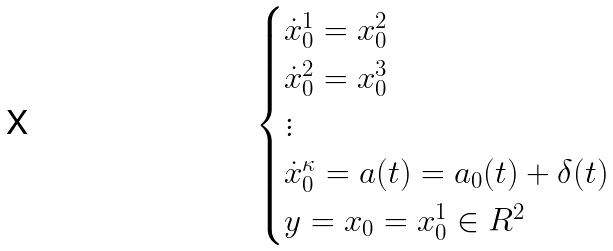<formula> <loc_0><loc_0><loc_500><loc_500>\begin{cases} \dot { x } _ { 0 } ^ { 1 } = x _ { 0 } ^ { 2 } \\ \dot { x } _ { 0 } ^ { 2 } = x _ { 0 } ^ { 3 } \\ \vdots \\ \dot { x } _ { 0 } ^ { \kappa } = a ( t ) = a _ { 0 } ( t ) + \delta ( t ) \\ y = x _ { 0 } = x _ { 0 } ^ { 1 } \in R ^ { 2 } \end{cases}</formula> 